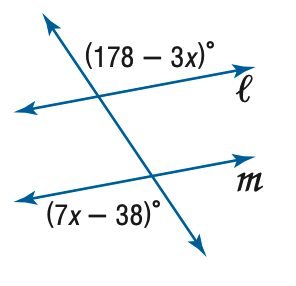Answer the mathemtical geometry problem and directly provide the correct option letter.
Question: Find x so that m \parallel n.
Choices: A: 14 B: 21.6 C: 28 D: 35 B 